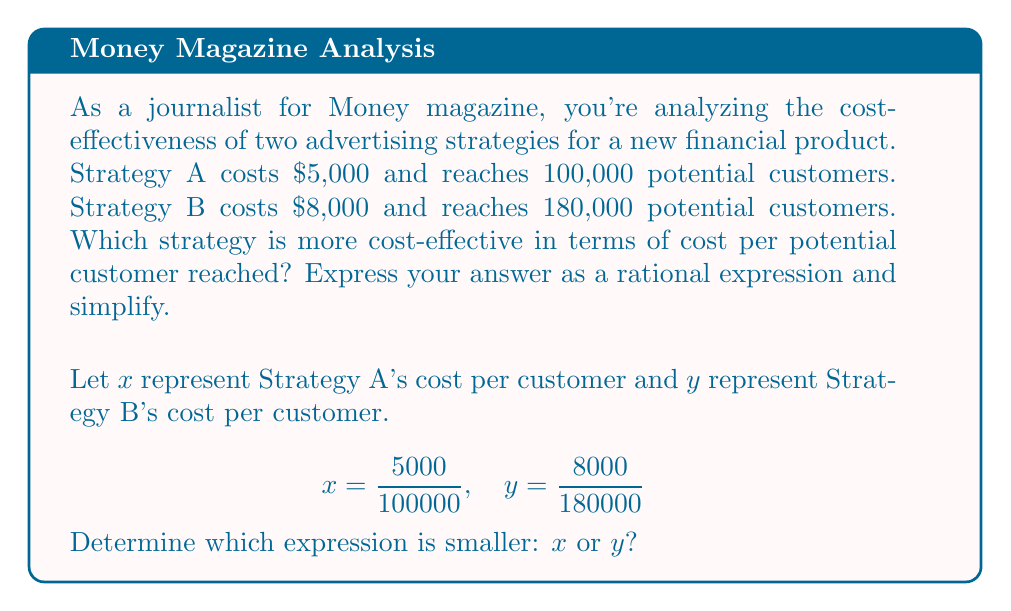Provide a solution to this math problem. To solve this problem, we need to evaluate and compare the two rational expressions:

1. For Strategy A:
   $$x = \frac{5000}{100000} = \frac{1}{20} = 0.05$$

2. For Strategy B:
   $$y = \frac{8000}{180000} = \frac{4}{90} \approx 0.0444$$

3. To compare these fractions more easily, let's find a common denominator:
   $$x = \frac{1}{20} = \frac{9}{180}$$
   $$y = \frac{4}{90} = \frac{8}{180}$$

4. Now we can directly compare:
   $$\frac{9}{180} > \frac{8}{180}$$

5. Therefore, $x > y$, which means Strategy B is more cost-effective.

The simplified rational expression for the difference in cost-effectiveness is:
$$x - y = \frac{9}{180} - \frac{8}{180} = \frac{1}{180}$$

This represents how much more cost-effective Strategy B is compared to Strategy A per potential customer reached.
Answer: Strategy B; $\frac{1}{180}$ per customer 